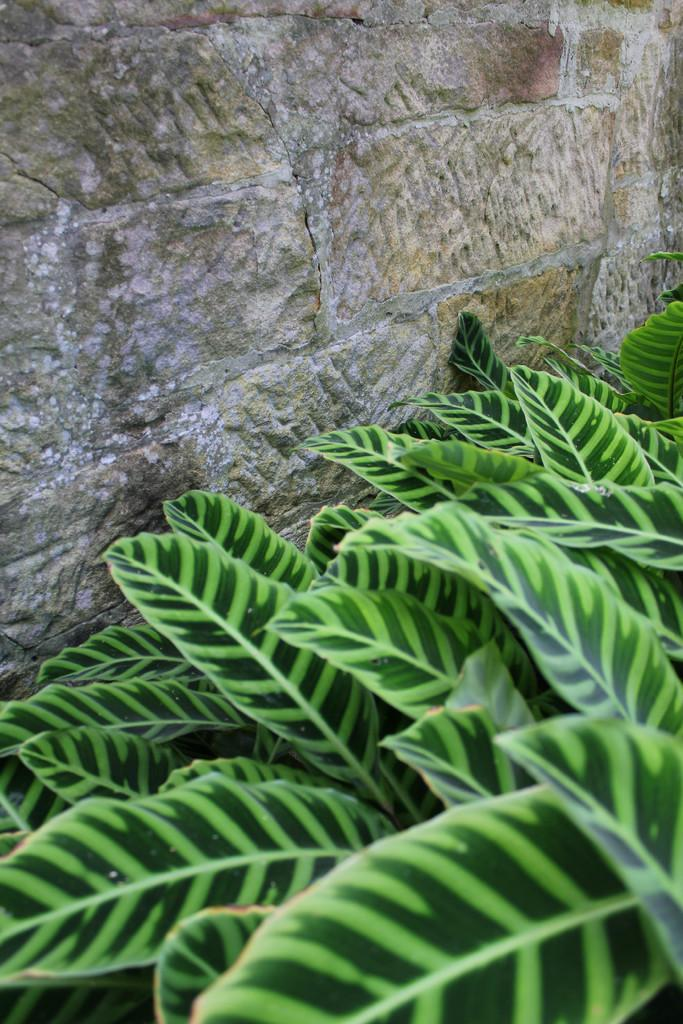What type of vegetation is present at the bottom of the image? There are plants at the bottom of the image. What structure can be seen at the top of the image? There is a wall at the top of the image. How many boats are visible in the image? There are no boats present in the image. What grade is the plant in the image? The provided facts do not mention any grades or classifications for the plants in the image. 